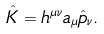Convert formula to latex. <formula><loc_0><loc_0><loc_500><loc_500>\hat { K } = h ^ { \mu \nu } { a } _ { \mu } \hat { p } _ { \nu } .</formula> 